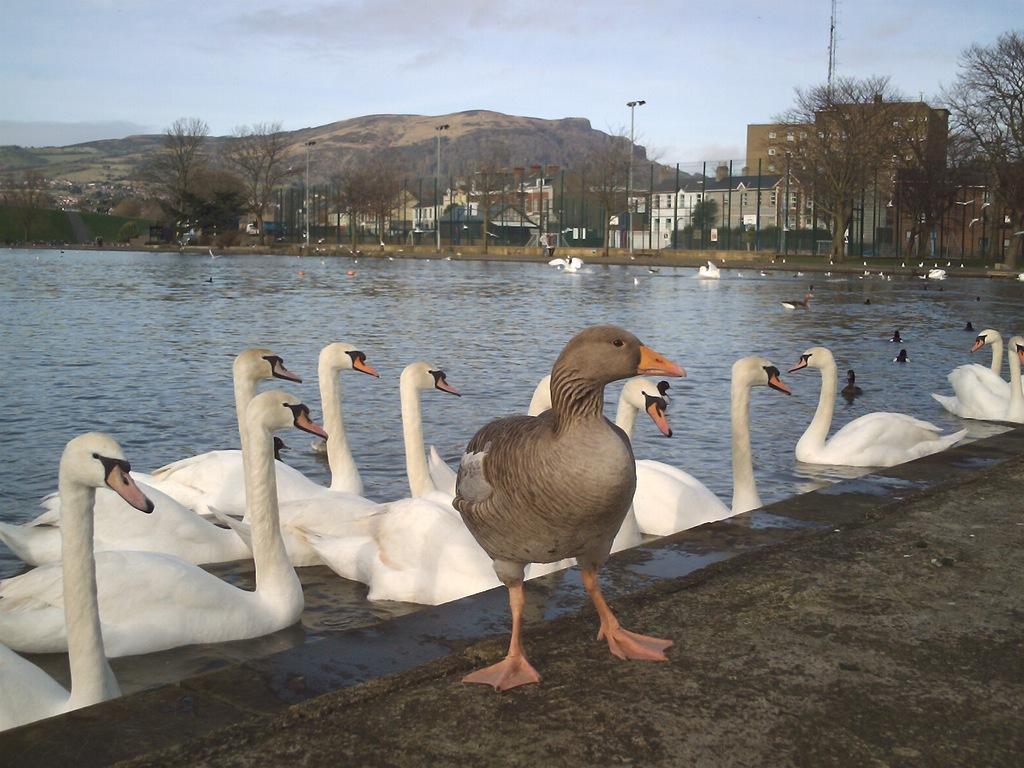In one or two sentences, can you explain what this image depicts? In the image I can see birds among them some are on the ground and some are swimming in the water. In the background I can see mountains, trees, street lights, fence, buildings, the sky and some other objects. 